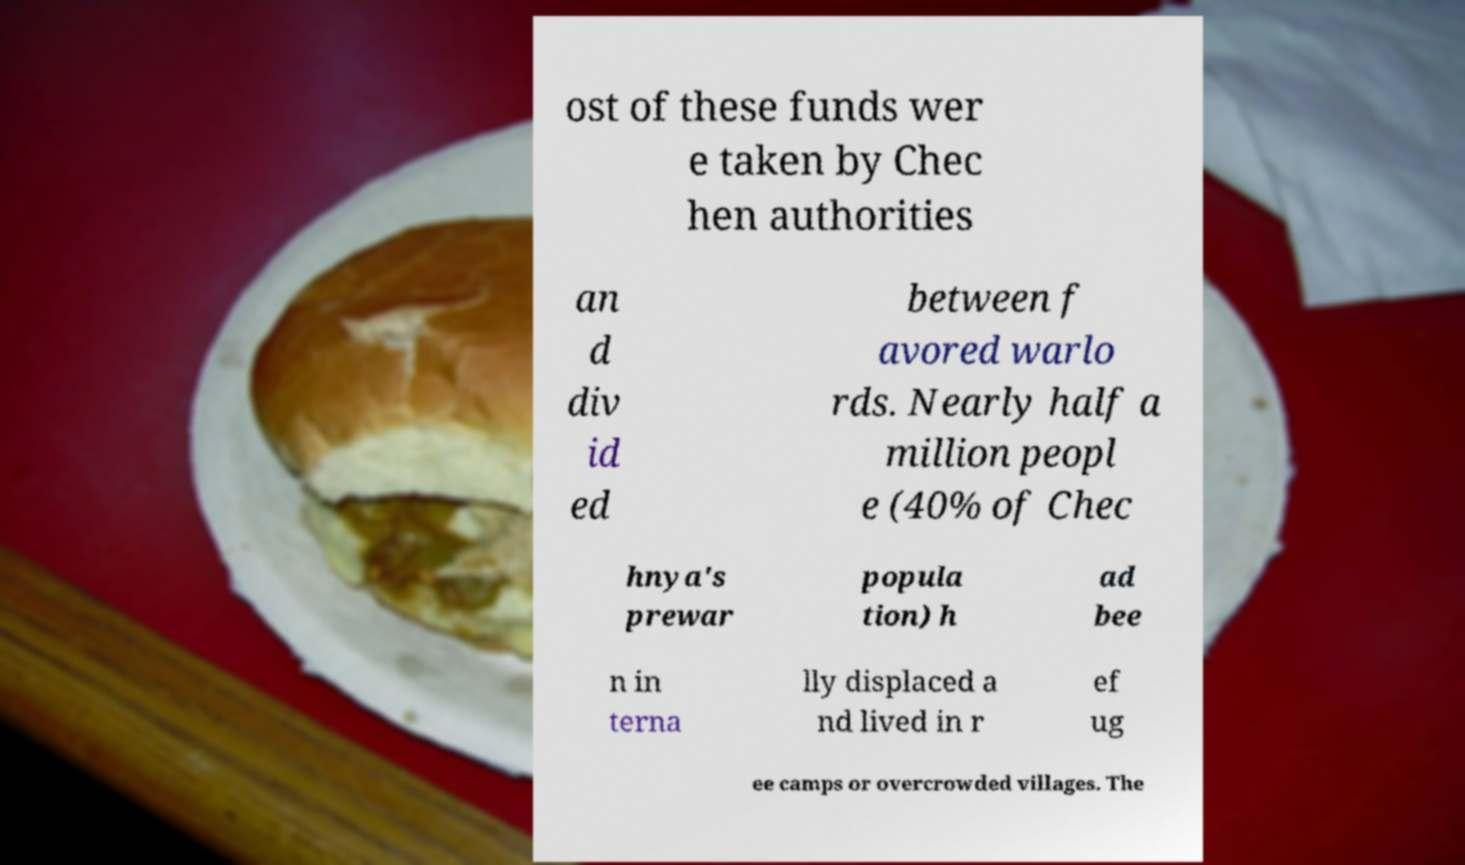Could you extract and type out the text from this image? ost of these funds wer e taken by Chec hen authorities an d div id ed between f avored warlo rds. Nearly half a million peopl e (40% of Chec hnya's prewar popula tion) h ad bee n in terna lly displaced a nd lived in r ef ug ee camps or overcrowded villages. The 